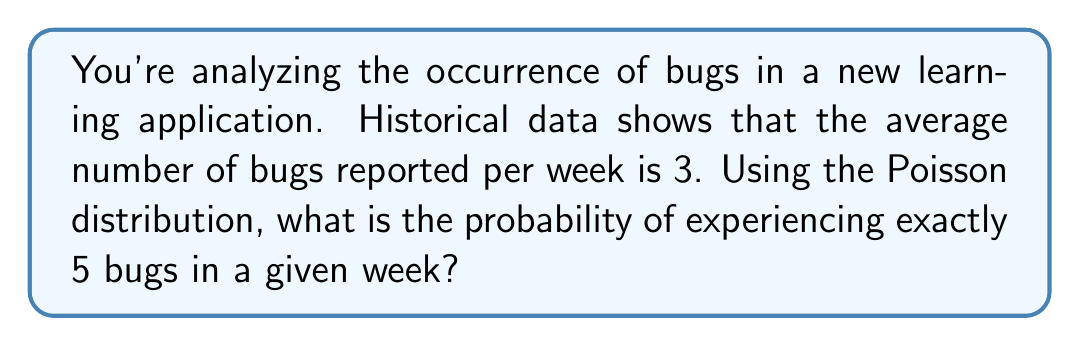Give your solution to this math problem. To solve this problem, we'll use the Poisson distribution formula:

$$P(X = k) = \frac{e^{-\lambda} \lambda^k}{k!}$$

Where:
$\lambda$ = average number of events in the given interval
$k$ = number of events we're calculating the probability for
$e$ = Euler's number (approximately 2.71828)

Given:
$\lambda = 3$ (average number of bugs per week)
$k = 5$ (we're calculating the probability of exactly 5 bugs)

Let's substitute these values into the formula:

$$P(X = 5) = \frac{e^{-3} 3^5}{5!}$$

Now, let's calculate step by step:

1) First, calculate $e^{-3}$:
   $e^{-3} \approx 0.0497871$

2) Calculate $3^5$:
   $3^5 = 243$

3) Calculate $5!$:
   $5! = 5 \times 4 \times 3 \times 2 \times 1 = 120$

4) Now, put it all together:
   $$P(X = 5) = \frac{0.0497871 \times 243}{120}$$

5) Simplify:
   $$P(X = 5) = \frac{12.0982653}{120} = 0.1008189$$

6) Round to 4 decimal places:
   $P(X = 5) \approx 0.1008$

Therefore, the probability of experiencing exactly 5 bugs in a given week is approximately 0.1008 or 10.08%.
Answer: 0.1008 